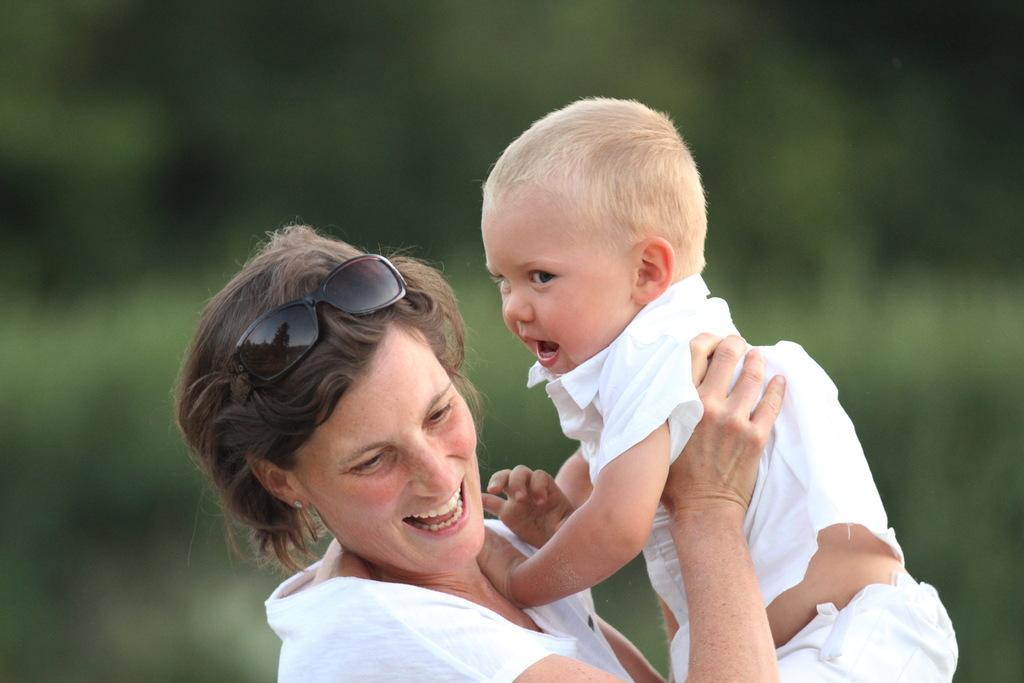Could you give a brief overview of what you see in this image? In this image at the bottom I can see a woman holding a baby and they both are smiling and baby wearing a white color t-shirt. 